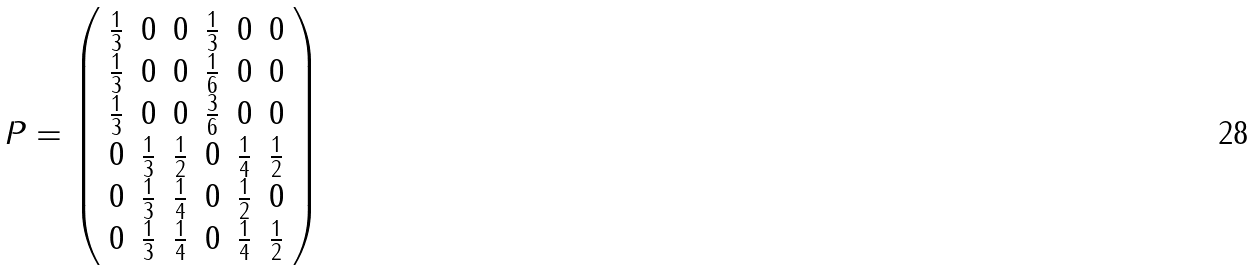<formula> <loc_0><loc_0><loc_500><loc_500>P = \left ( \begin{array} { c c c c c c } \frac { 1 } { 3 } & 0 & 0 & \frac { 1 } { 3 } & 0 & 0 \\ \frac { 1 } { 3 } & 0 & 0 & \frac { 1 } { 6 } & 0 & 0 \\ \frac { 1 } { 3 } & 0 & 0 & \frac { 3 } { 6 } & 0 & 0 \\ 0 & \frac { 1 } { 3 } & \frac { 1 } { 2 } & 0 & \frac { 1 } { 4 } & \frac { 1 } { 2 } \\ 0 & \frac { 1 } { 3 } & \frac { 1 } { 4 } & 0 & \frac { 1 } { 2 } & 0 \\ 0 & \frac { 1 } { 3 } & \frac { 1 } { 4 } & 0 & \frac { 1 } { 4 } & \frac { 1 } { 2 } \\ \end{array} \right )</formula> 